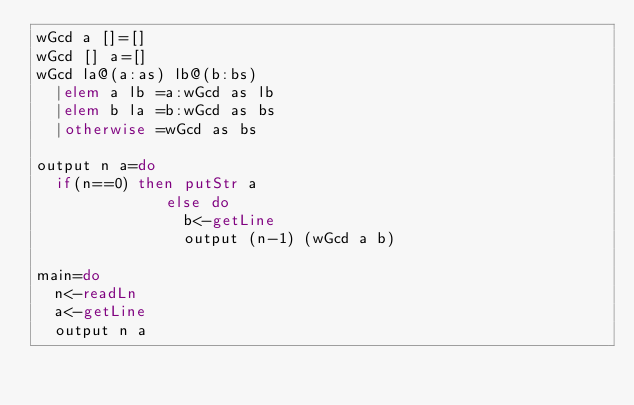<code> <loc_0><loc_0><loc_500><loc_500><_Haskell_>wGcd a []=[]
wGcd [] a=[]
wGcd la@(a:as) lb@(b:bs)
  |elem a lb =a:wGcd as lb
  |elem b la =b:wGcd as bs
  |otherwise =wGcd as bs
 
output n a=do
  if(n==0) then putStr a
              else do 
                b<-getLine
                output (n-1) (wGcd a b)
 
main=do
  n<-readLn
  a<-getLine
  output n a</code> 